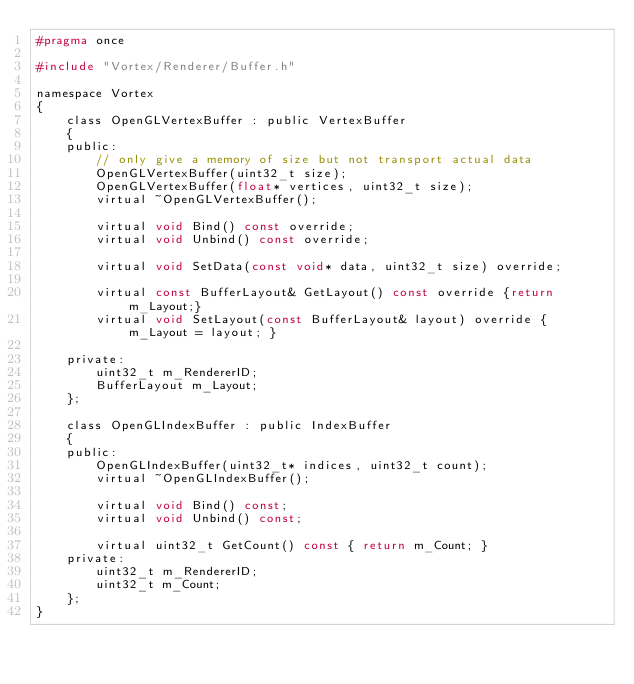<code> <loc_0><loc_0><loc_500><loc_500><_C_>#pragma once

#include "Vortex/Renderer/Buffer.h"

namespace Vortex 
{
    class OpenGLVertexBuffer : public VertexBuffer
    {
    public:
        // only give a memory of size but not transport actual data
        OpenGLVertexBuffer(uint32_t size);
        OpenGLVertexBuffer(float* vertices, uint32_t size);
        virtual ~OpenGLVertexBuffer();

        virtual void Bind() const override;
        virtual void Unbind() const override;

        virtual void SetData(const void* data, uint32_t size) override;

        virtual const BufferLayout& GetLayout() const override {return m_Layout;}
        virtual void SetLayout(const BufferLayout& layout) override { m_Layout = layout; }

    private:
        uint32_t m_RendererID;
        BufferLayout m_Layout;
    };

    class OpenGLIndexBuffer : public IndexBuffer
    {
    public:
        OpenGLIndexBuffer(uint32_t* indices, uint32_t count);
        virtual ~OpenGLIndexBuffer();

        virtual void Bind() const;
        virtual void Unbind() const;

        virtual uint32_t GetCount() const { return m_Count; }
    private:
        uint32_t m_RendererID;
        uint32_t m_Count;
    };
}
</code> 